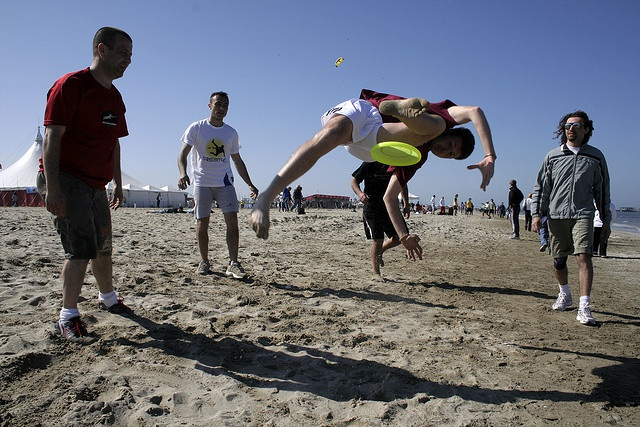Describe the objects in this image and their specific colors. I can see people in darkgray, black, gray, and maroon tones, people in darkgray, black, and gray tones, people in darkgray, black, and gray tones, people in darkgray, black, and gray tones, and people in darkgray, black, and gray tones in this image. 